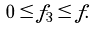Convert formula to latex. <formula><loc_0><loc_0><loc_500><loc_500>0 \leq f _ { 3 } \leq f .</formula> 